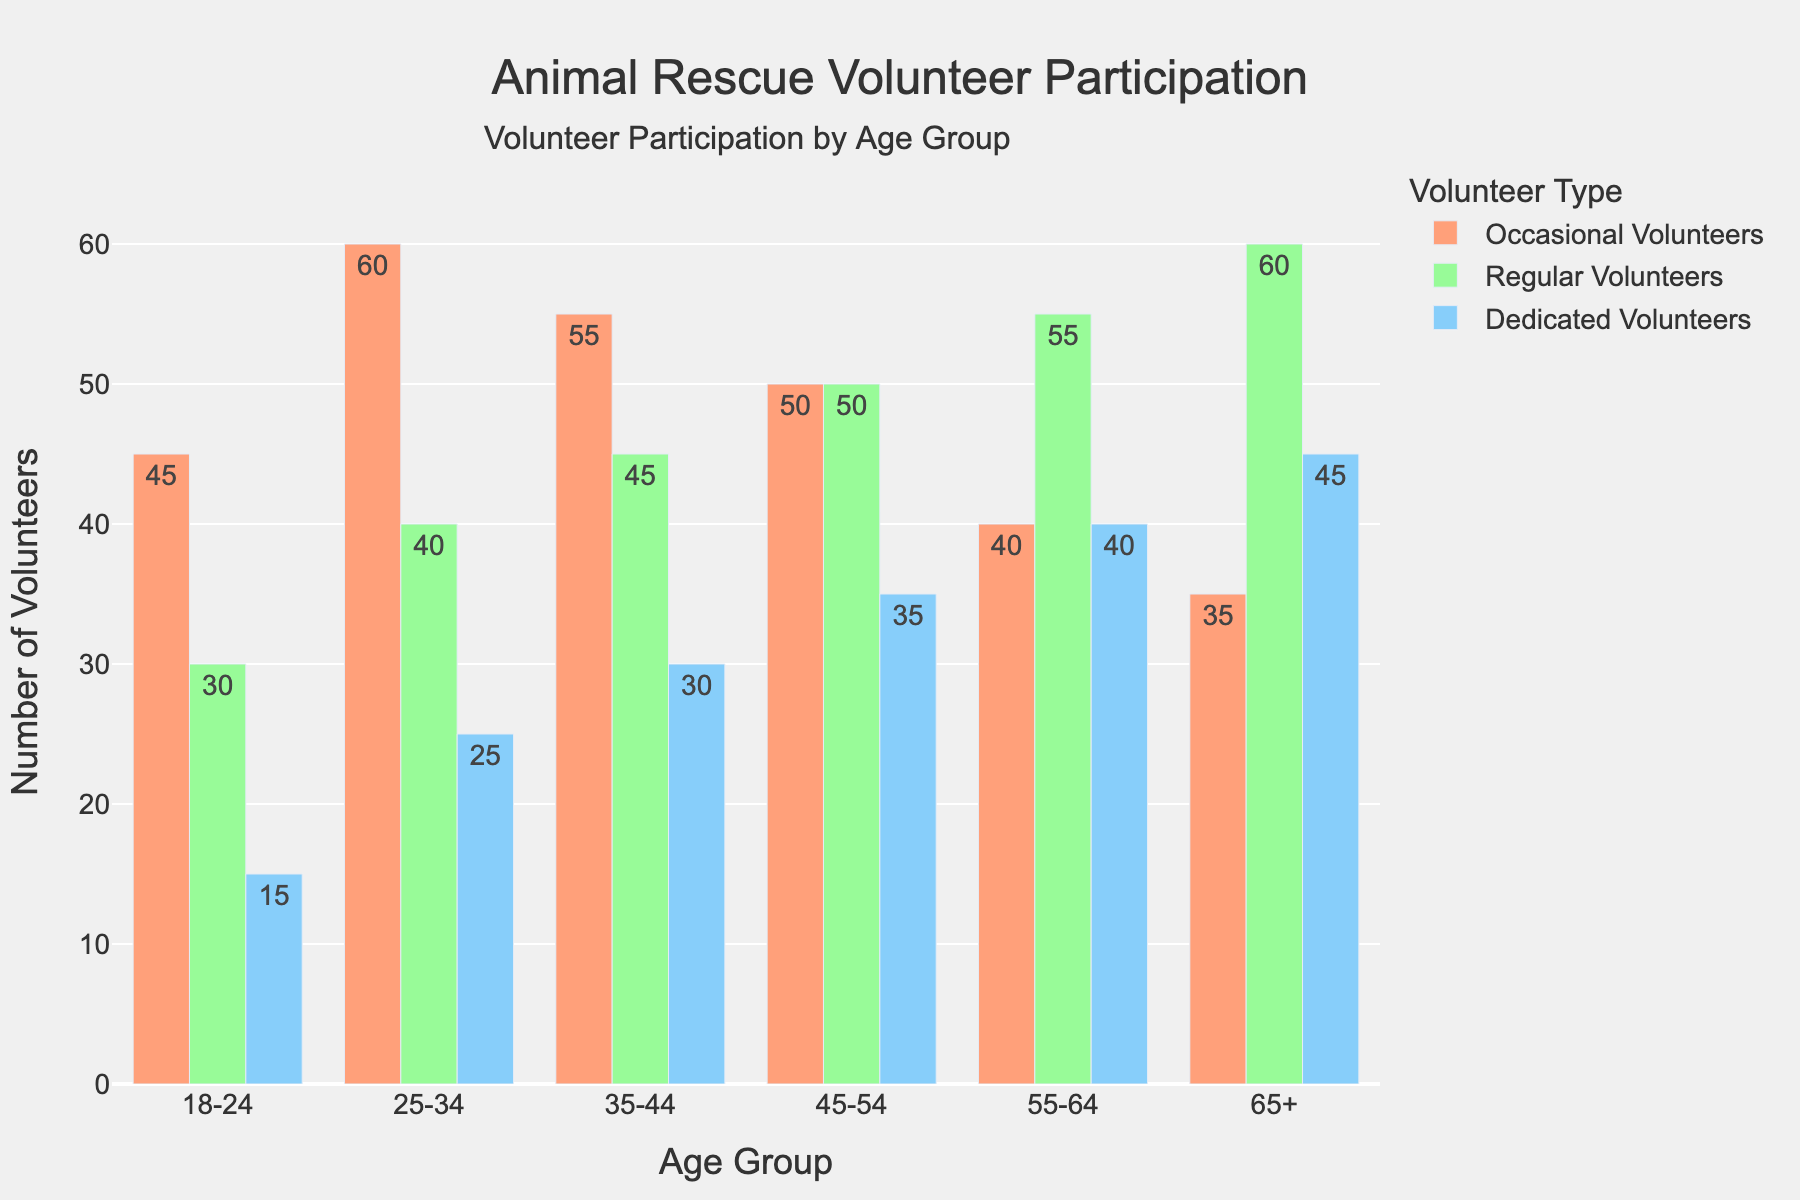What is the total number of volunteers in the 45-54 age group across all commitment levels? Add the values of Occasional Volunteers, Regular Volunteers, and Dedicated Volunteers for the 45-54 age group: 50 + 50 + 35 = 135.
Answer: 135 Which age group has the highest number of Regular Volunteers? Compare the values of Regular Volunteers across all age groups. The 65+ age group has the highest value with 60 Regular Volunteers.
Answer: 65+ How does the number of Dedicated Volunteers in the 18-24 age group compare to the 25-34 age group? Compare the values of Dedicated Volunteers: the 18-24 age group has 15, and the 25-34 age group has 25. 25 is greater than 15.
Answer: The 25-34 age group has more What is the average number of Occasional Volunteers across all age groups? Sum the Occasional Volunteers across all age groups and divide by the number of age groups: (45 + 60 + 55 + 50 + 40 + 35) / 6 = 285 / 6 = 47.5.
Answer: 47.5 Between the 35-44 and 55-64 age groups, which has a greater total number of volunteers across all commitment levels? Sum the values for each group: 35-44 has 55 + 45 + 30 = 130 and 55-64 has 40 + 55 + 40 = 135. Compare the totals: 135 is greater than 130.
Answer: 55-64 Which category of volunteers shows the most significant increase in number between the 18-24 and 65+ age groups? Compare the differences for each category: Occasional: 35 - 45 = -10, Regular: 60 - 30 = 30, Dedicated: 45 - 15 = 30. Both Regular and Dedicated Volunteers show the highest increase of 30.
Answer: Regular and Dedicated Volunteers What is the proportion of Dedicated Volunteers to the total number of volunteers in the 55-64 age group? Calculate the proportion: (40 / (40 + 55 + 40)) = 40 / 135 ≈ 0.296.
Answer: Approximately 0.296 In which age group do Regular Volunteers outnumber Occasional Volunteers the most? Compare the differences between Regular and Occasional Volunteers for each age group. The largest difference is in the 65+ age group: 60 - 35 = 25.
Answer: 65+ How does the total number of volunteers in the 25-34 age group compare to the 45-54 age group? Compare the sums: for 25-34 = 60 + 40 + 25 = 125, for 45-54 = 50 + 50 + 35 = 135. 135 is greater than 125.
Answer: The 45-54 age group has more 